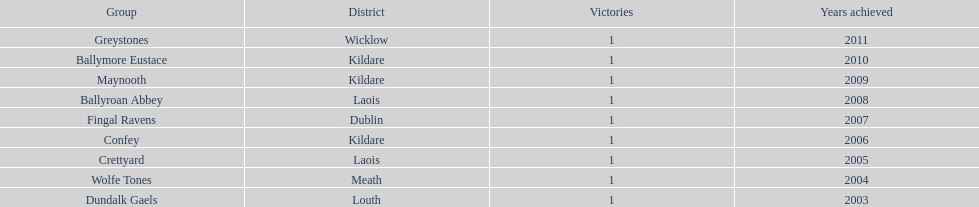Could you help me parse every detail presented in this table? {'header': ['Group', 'District', 'Victories', 'Years achieved'], 'rows': [['Greystones', 'Wicklow', '1', '2011'], ['Ballymore Eustace', 'Kildare', '1', '2010'], ['Maynooth', 'Kildare', '1', '2009'], ['Ballyroan Abbey', 'Laois', '1', '2008'], ['Fingal Ravens', 'Dublin', '1', '2007'], ['Confey', 'Kildare', '1', '2006'], ['Crettyard', 'Laois', '1', '2005'], ['Wolfe Tones', 'Meath', '1', '2004'], ['Dundalk Gaels', 'Louth', '1', '2003']]} What is the total of wins on the chart 9. 